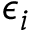Convert formula to latex. <formula><loc_0><loc_0><loc_500><loc_500>\epsilon _ { i }</formula> 